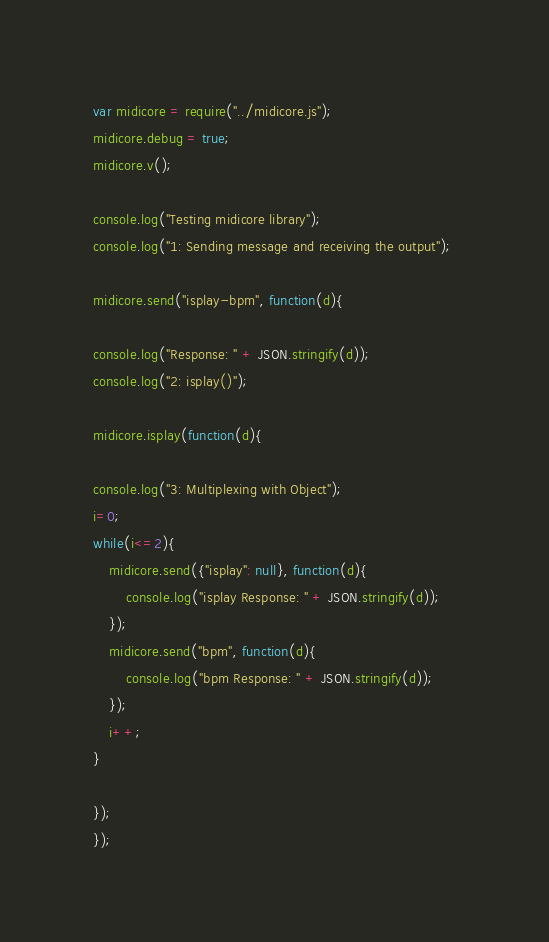<code> <loc_0><loc_0><loc_500><loc_500><_JavaScript_>var midicore = require("../midicore.js");
midicore.debug = true;
midicore.v();

console.log("Testing midicore library");
console.log("1: Sending message and receiving the output");

midicore.send("isplay-bpm", function(d){

console.log("Response: " + JSON.stringify(d));
console.log("2: isplay()");

midicore.isplay(function(d){

console.log("3: Multiplexing with Object");
i=0;
while(i<=2){
	midicore.send({"isplay": null}, function(d){
		console.log("isplay Response: " + JSON.stringify(d));	
	});
	midicore.send("bpm", function(d){
		console.log("bpm Response: " + JSON.stringify(d));	
	});
	i++;
}

});
});
</code> 